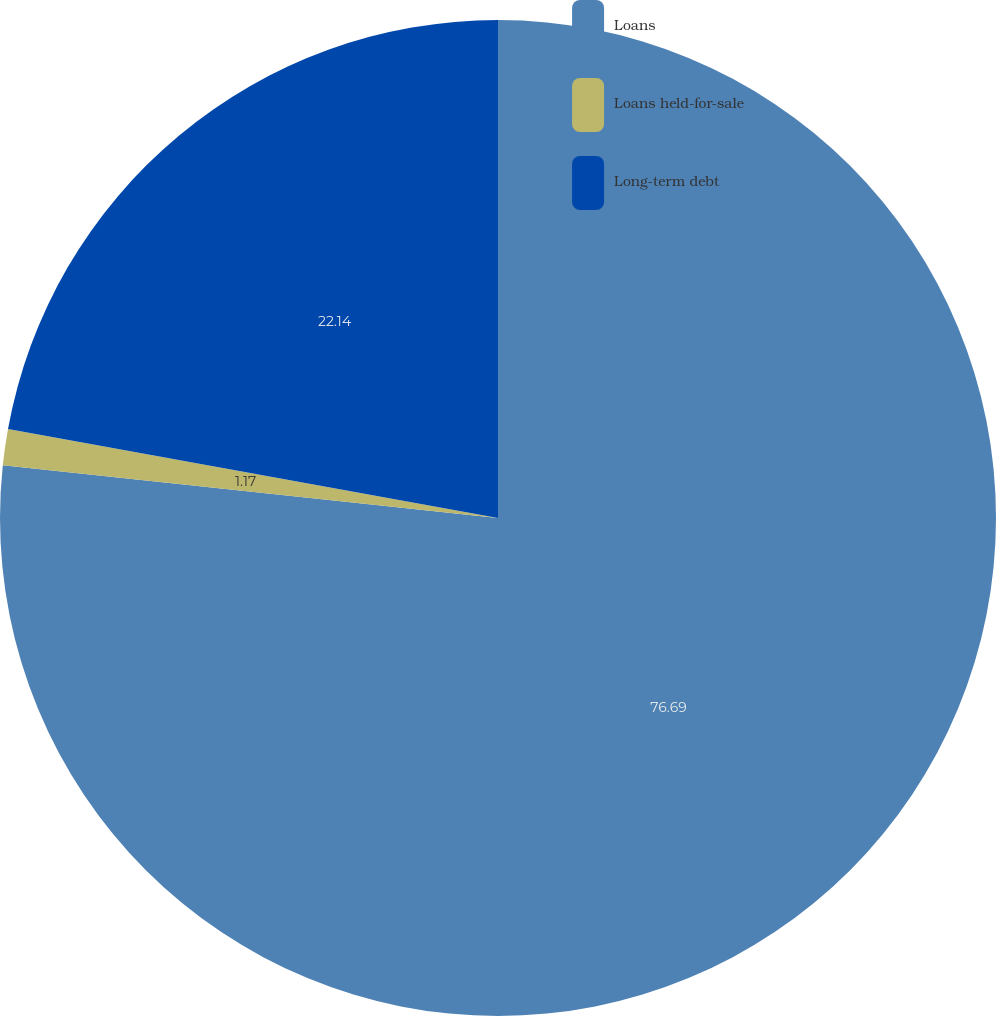Convert chart to OTSL. <chart><loc_0><loc_0><loc_500><loc_500><pie_chart><fcel>Loans<fcel>Loans held-for-sale<fcel>Long-term debt<nl><fcel>76.69%<fcel>1.17%<fcel>22.14%<nl></chart> 